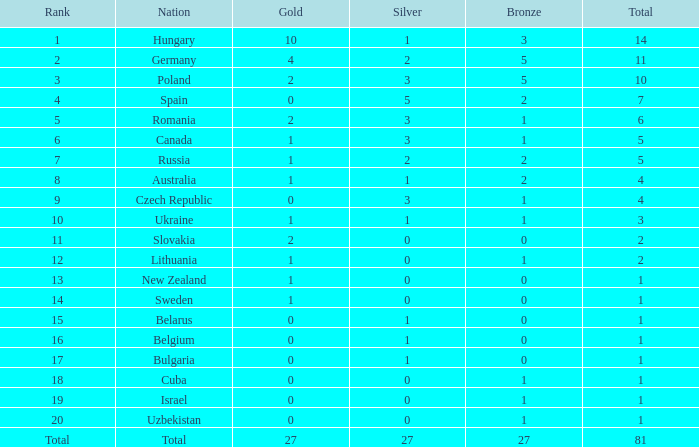What is the quantity of bronze with a gold greater than 1, a silver less than 3, belonging to germany, and a total exceeding 11? 0.0. 